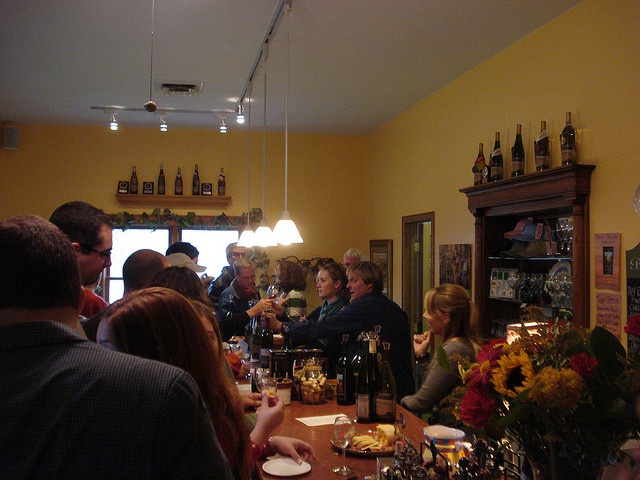Describe the objects in this image and their specific colors. I can see people in darkgreen, black, maroon, and gray tones, dining table in darkgreen, black, maroon, and brown tones, people in darkgreen, black, maroon, and purple tones, people in darkgreen, black, maroon, and olive tones, and people in darkgreen, black, maroon, and brown tones in this image. 